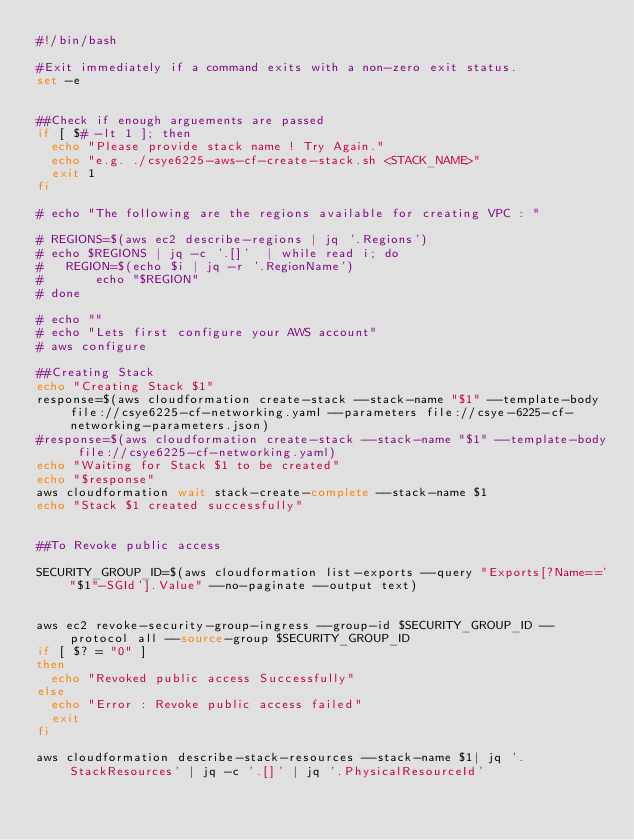Convert code to text. <code><loc_0><loc_0><loc_500><loc_500><_Bash_>#!/bin/bash

#Exit immediately if a command exits with a non-zero exit status.
set -e


##Check if enough arguements are passed
if [ $# -lt 1 ]; then
  echo "Please provide stack name ! Try Again."
  echo "e.g. ./csye6225-aws-cf-create-stack.sh <STACK_NAME>"
  exit 1
fi

# echo "The following are the regions available for creating VPC : "

# REGIONS=$(aws ec2 describe-regions | jq '.Regions')
# echo $REGIONS | jq -c '.[]'  | while read i; do
# 	REGION=$(echo $i | jq -r '.RegionName')
# 	    echo "$REGION"
# done

# echo ""
# echo "Lets first configure your AWS account"
# aws configure

##Creating Stack
echo "Creating Stack $1"
response=$(aws cloudformation create-stack --stack-name "$1" --template-body file://csye6225-cf-networking.yaml --parameters file://csye-6225-cf-networking-parameters.json) 
#response=$(aws cloudformation create-stack --stack-name "$1" --template-body file://csye6225-cf-networking.yaml)
echo "Waiting for Stack $1 to be created"
echo "$response"
aws cloudformation wait stack-create-complete --stack-name $1
echo "Stack $1 created successfully"


##To Revoke public access

SECURITY_GROUP_ID=$(aws cloudformation list-exports --query "Exports[?Name=='"$1"-SGId'].Value" --no-paginate --output text)


aws ec2 revoke-security-group-ingress --group-id $SECURITY_GROUP_ID --protocol all --source-group $SECURITY_GROUP_ID
if [ $? = "0" ]
then
	echo "Revoked public access Successfully"
else
	echo "Error : Revoke public access failed"
	exit
fi

aws cloudformation describe-stack-resources --stack-name $1| jq '.StackResources' | jq -c '.[]' | jq '.PhysicalResourceId'

</code> 